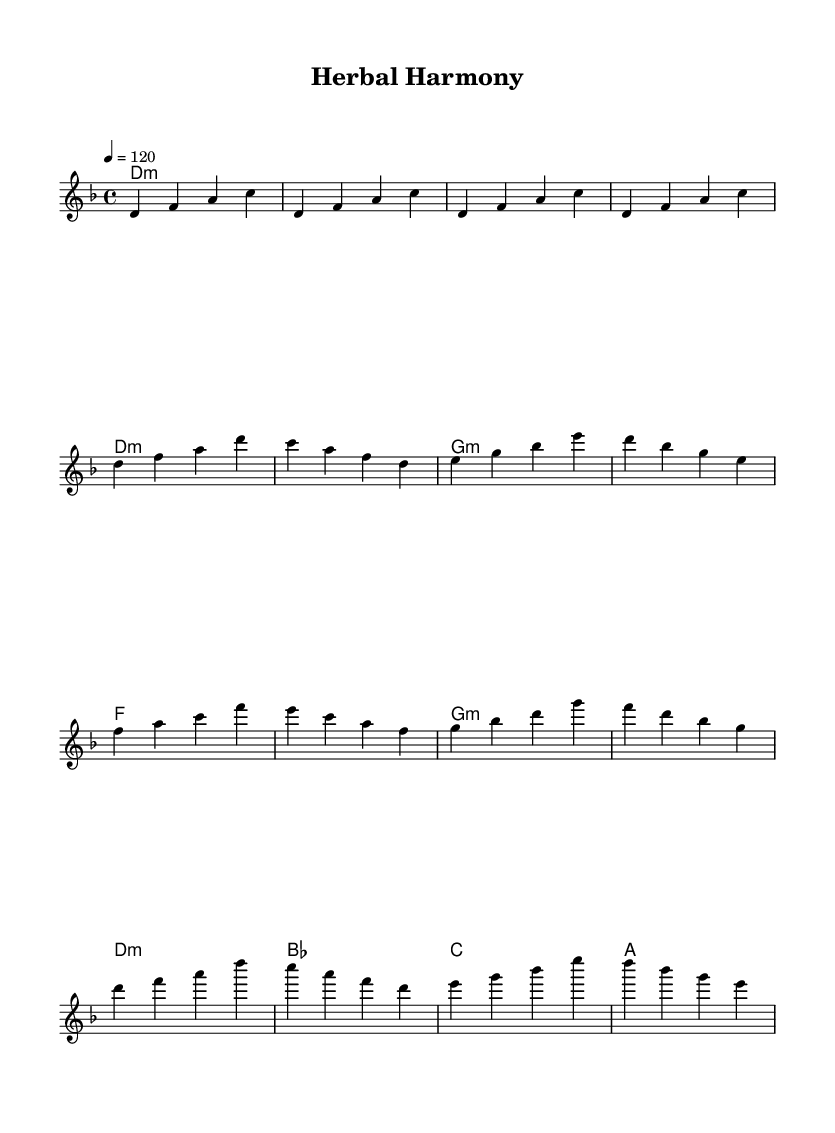What is the key signature of this music? The key signature is D minor, which is indicated by one flat (B flat). This is determined by looking at the global settings at the top of the sheet music, where it specifies the key as D minor.
Answer: D minor What is the time signature of this music? The time signature is 4/4, which is shown at the beginning of the sheet music. This means there are four beats in each measure, and the quarter note gets one beat.
Answer: 4/4 What is the tempo marking for this music? The tempo marking is 120 beats per minute, noted in the global settings. This serves as a guide for how fast the piece should be played.
Answer: 120 How many measures are in the chorus section? There are four measures in the chorus section, which can be identified by examining the melodic and harmonic notation under the chorus labeling.
Answer: 4 What chord follows the G minor chord in the pre-chorus? The chord that follows the G minor chord in the pre-chorus is F major. This is found by looking at the harmony sequence in the pre-chorus section, where the order of chords is established.
Answer: F Which section of the music does the melody start with the note D? The melody starts with the note D in both the intro and the verse sections. By checking the note notations in these sections, you can see that it begins with D in several measures.
Answer: Intro and Verse What type of progression is predominantly used in the verse? The predominant chord progression in the verse is based primarily on minor chords. Analyzing the harmony for the verse shows it utilizes D minor and G minor, indicating a reliance on minor tonalities.
Answer: Minor 